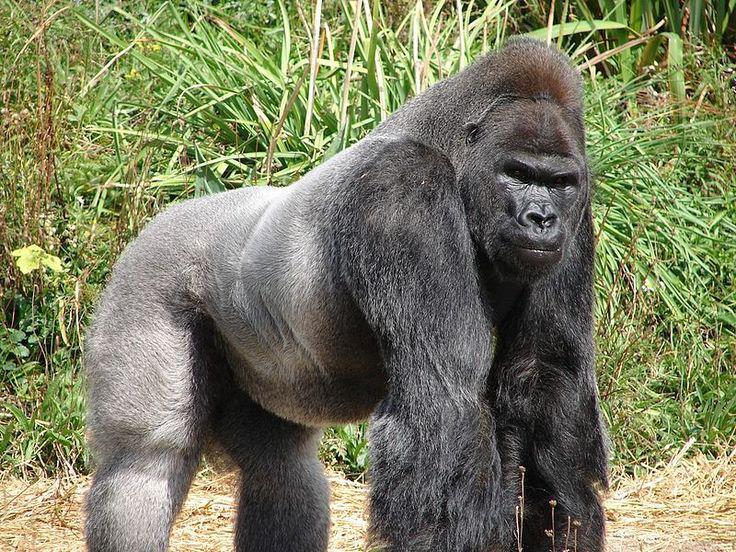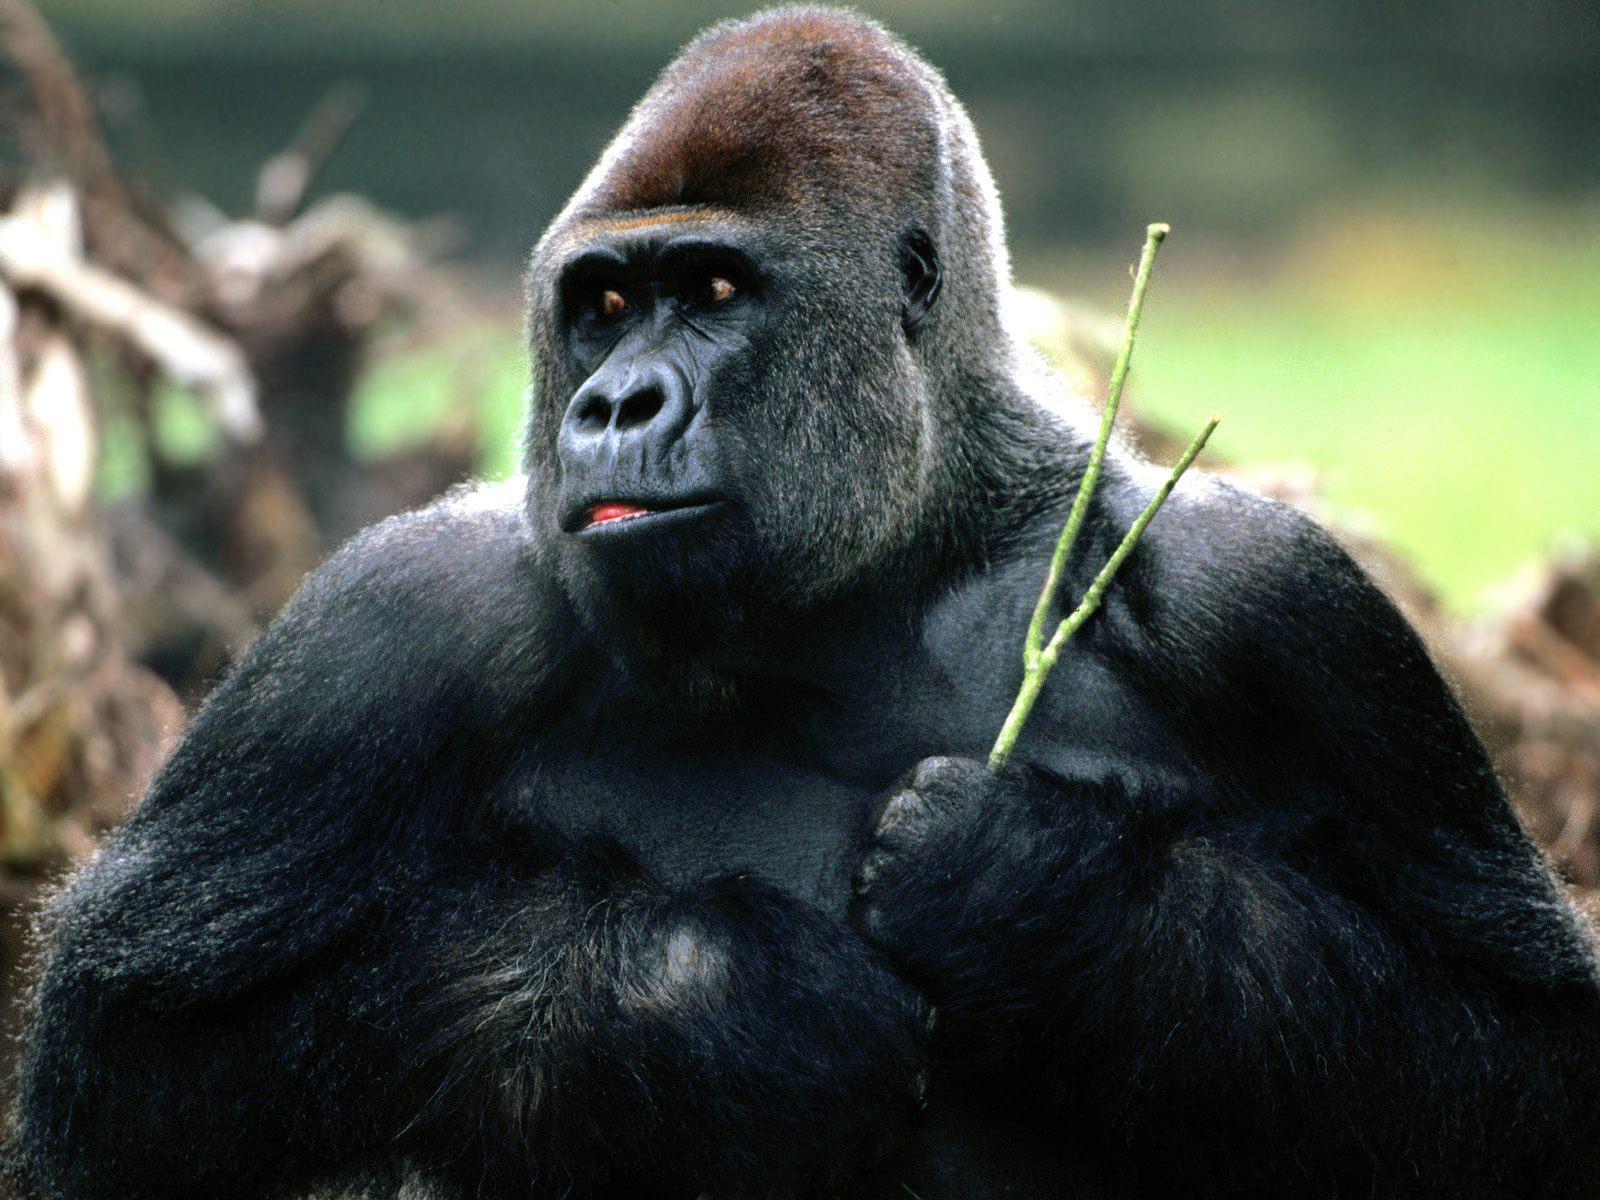The first image is the image on the left, the second image is the image on the right. Analyze the images presented: Is the assertion "One image includes a baby gorilla with its mother." valid? Answer yes or no. No. 